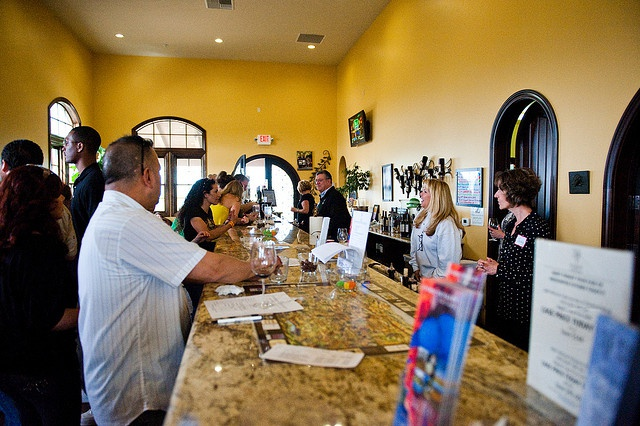Describe the objects in this image and their specific colors. I can see people in black, darkgray, gray, and lightgray tones, people in black, maroon, and darkgray tones, people in black, lightpink, gray, and brown tones, people in black, darkgray, lavender, and lightgray tones, and people in black, darkgray, maroon, and gray tones in this image. 